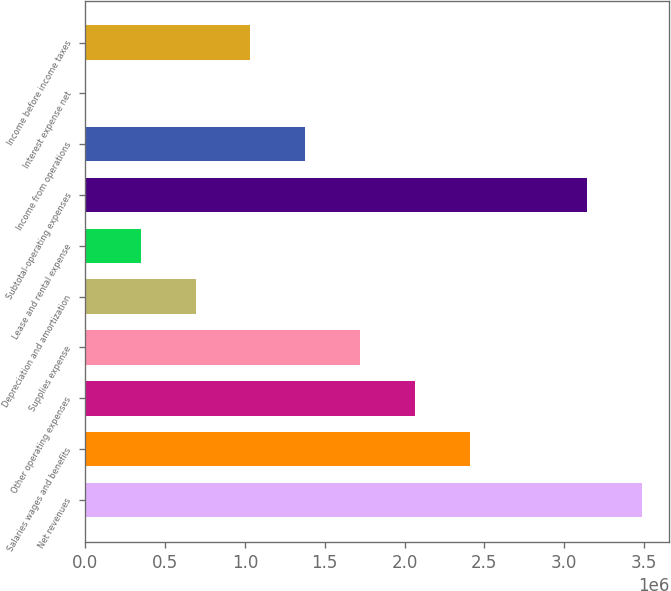<chart> <loc_0><loc_0><loc_500><loc_500><bar_chart><fcel>Net revenues<fcel>Salaries wages and benefits<fcel>Other operating expenses<fcel>Supplies expense<fcel>Depreciation and amortization<fcel>Lease and rental expense<fcel>Subtotal-operating expenses<fcel>Income from operations<fcel>Interest expense net<fcel>Income before income taxes<nl><fcel>3.48528e+06<fcel>2.40795e+06<fcel>2.06464e+06<fcel>1.72134e+06<fcel>691425<fcel>348120<fcel>3.14198e+06<fcel>1.37803e+06<fcel>4815<fcel>1.03473e+06<nl></chart> 